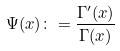<formula> <loc_0><loc_0><loc_500><loc_500>\Psi ( x ) \colon = \frac { \Gamma ^ { \prime } ( x ) } { \Gamma ( x ) }</formula> 